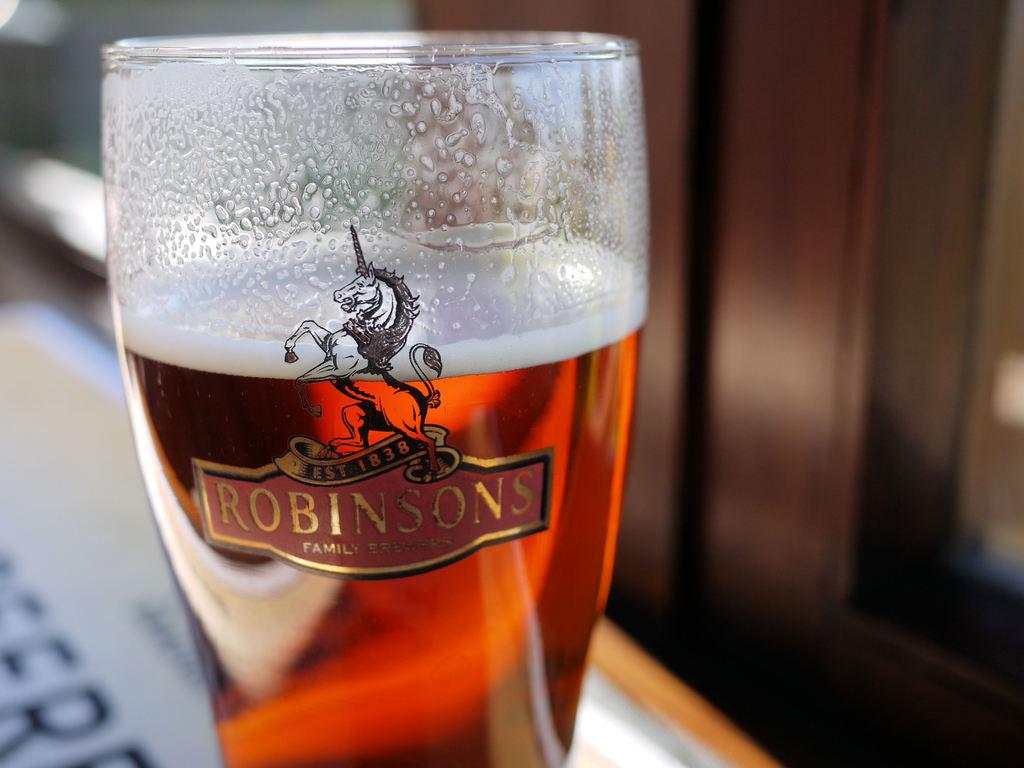What brand of beer is this?
Your answer should be compact. Robinsons. What kind of brewers are the robinsons?
Your answer should be very brief. Family. 